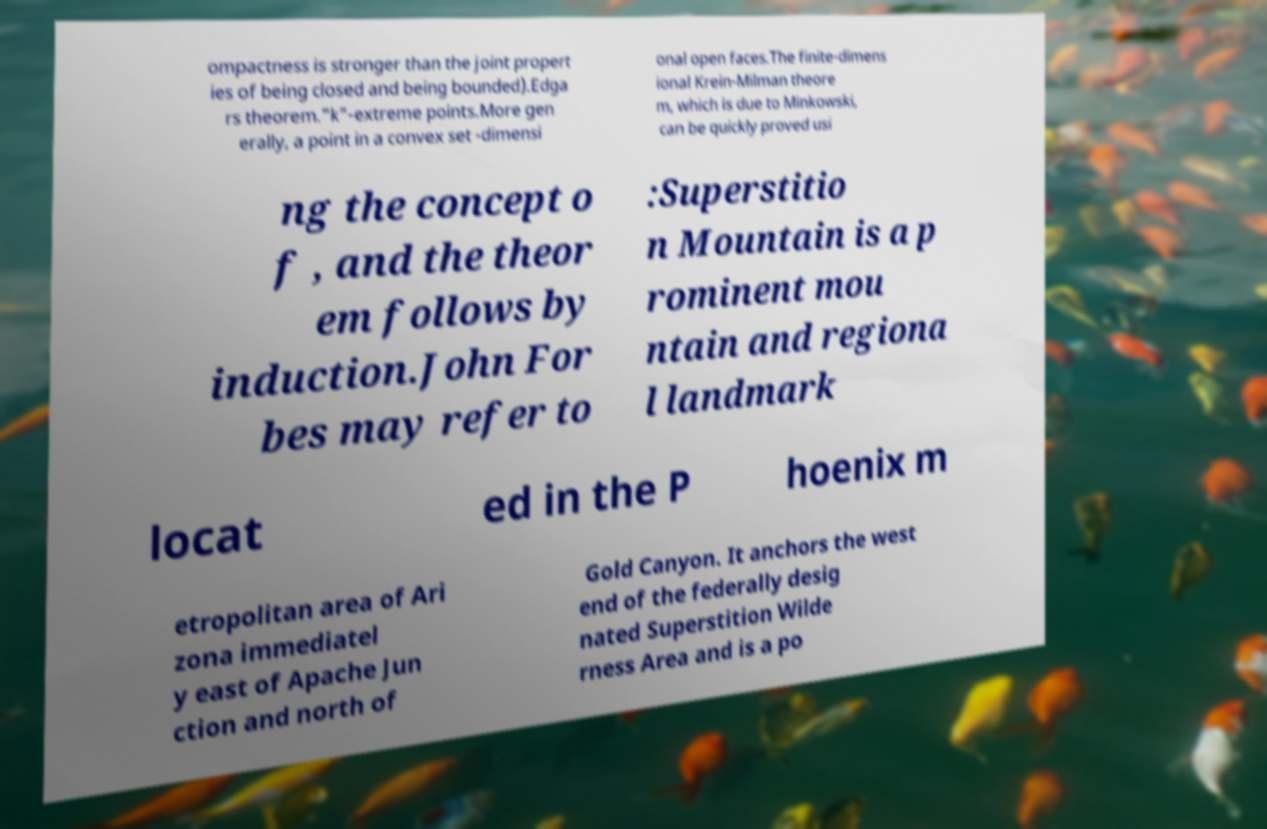Could you assist in decoding the text presented in this image and type it out clearly? ompactness is stronger than the joint propert ies of being closed and being bounded).Edga rs theorem."k"-extreme points.More gen erally, a point in a convex set -dimensi onal open faces.The finite-dimens ional Krein-Milman theore m, which is due to Minkowski, can be quickly proved usi ng the concept o f , and the theor em follows by induction.John For bes may refer to :Superstitio n Mountain is a p rominent mou ntain and regiona l landmark locat ed in the P hoenix m etropolitan area of Ari zona immediatel y east of Apache Jun ction and north of Gold Canyon. It anchors the west end of the federally desig nated Superstition Wilde rness Area and is a po 